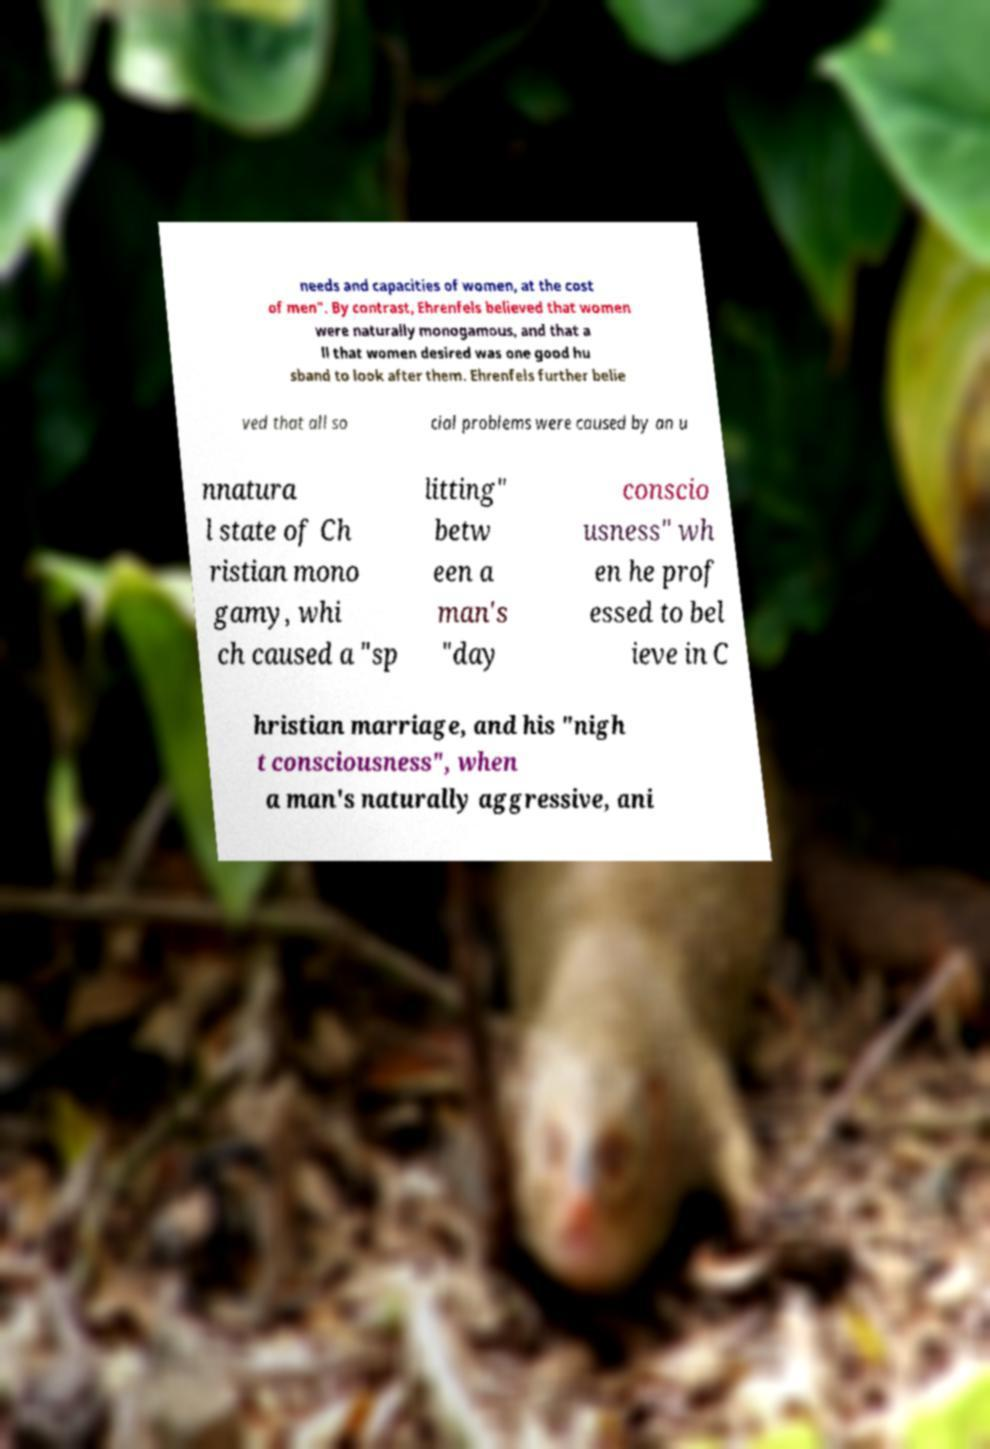Can you read and provide the text displayed in the image?This photo seems to have some interesting text. Can you extract and type it out for me? needs and capacities of women, at the cost of men". By contrast, Ehrenfels believed that women were naturally monogamous, and that a ll that women desired was one good hu sband to look after them. Ehrenfels further belie ved that all so cial problems were caused by an u nnatura l state of Ch ristian mono gamy, whi ch caused a "sp litting" betw een a man's "day conscio usness" wh en he prof essed to bel ieve in C hristian marriage, and his "nigh t consciousness", when a man's naturally aggressive, ani 